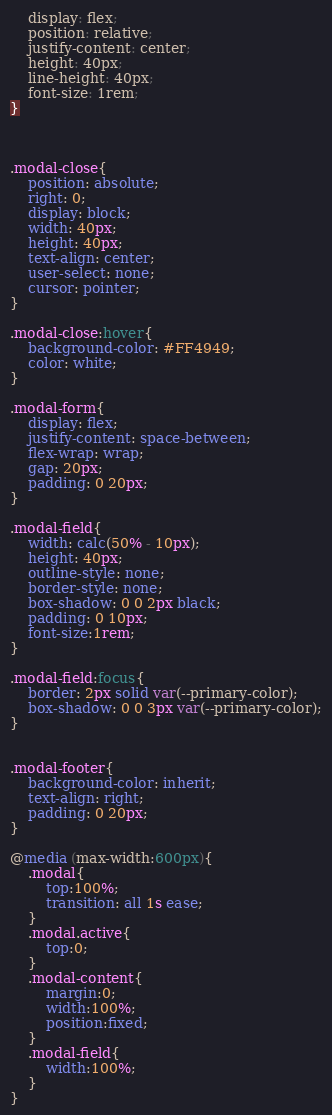Convert code to text. <code><loc_0><loc_0><loc_500><loc_500><_CSS_>    display: flex;
    position: relative;
    justify-content: center;
    height: 40px;
    line-height: 40px;
    font-size: 1rem;
}



.modal-close{
    position: absolute;
    right: 0;
    display: block;
    width: 40px;
    height: 40px;
    text-align: center;
    user-select: none;
    cursor: pointer;
}

.modal-close:hover{
    background-color: #FF4949;
    color: white;
}

.modal-form{
    display: flex;
    justify-content: space-between;
    flex-wrap: wrap;
    gap: 20px;
    padding: 0 20px;
}

.modal-field{
    width: calc(50% - 10px);
    height: 40px;
    outline-style: none;
    border-style: none;
    box-shadow: 0 0 2px black;
    padding: 0 10px;
    font-size:1rem;
}

.modal-field:focus{
    border: 2px solid var(--primary-color);
    box-shadow: 0 0 3px var(--primary-color);
}


.modal-footer{
    background-color: inherit;
    text-align: right;
    padding: 0 20px;
}

@media (max-width:600px){
    .modal{
        top:100%;
        transition: all 1s ease;
    }
    .modal.active{
        top:0;
    }
    .modal-content{
        margin:0;
        width:100%;
        position:fixed;
    }
    .modal-field{
        width:100%;
    }
}</code> 